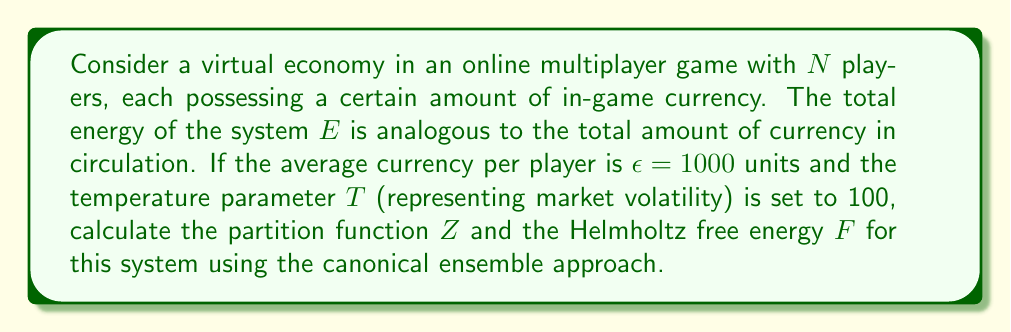Give your solution to this math problem. To solve this problem, we'll use the principles of statistical mechanics and the canonical ensemble:

1. Define the partition function:
   The partition function for the canonical ensemble is given by:
   $$Z = \sum_i e^{-\beta E_i}$$
   where $\beta = \frac{1}{k_B T}$, $k_B$ is the Boltzmann constant (which we'll set to 1 for simplicity), and $E_i$ are the possible energy states.

2. Calculate $\beta$:
   $$\beta = \frac{1}{T} = \frac{1}{100} = 0.01$$

3. Estimate the total energy:
   $$E = N \epsilon = N \times 1000$$

4. Simplify the partition function:
   Assuming a single macrostate for simplicity:
   $$Z = e^{-\beta E} = e^{-0.01 \times N \times 1000} = e^{-10N}$$

5. Calculate the Helmholtz free energy:
   The Helmholtz free energy is defined as:
   $$F = -k_B T \ln Z$$
   Substituting our values:
   $$F = -100 \ln(e^{-10N}) = 1000N$$
Answer: $Z = e^{-10N}$, $F = 1000N$ 